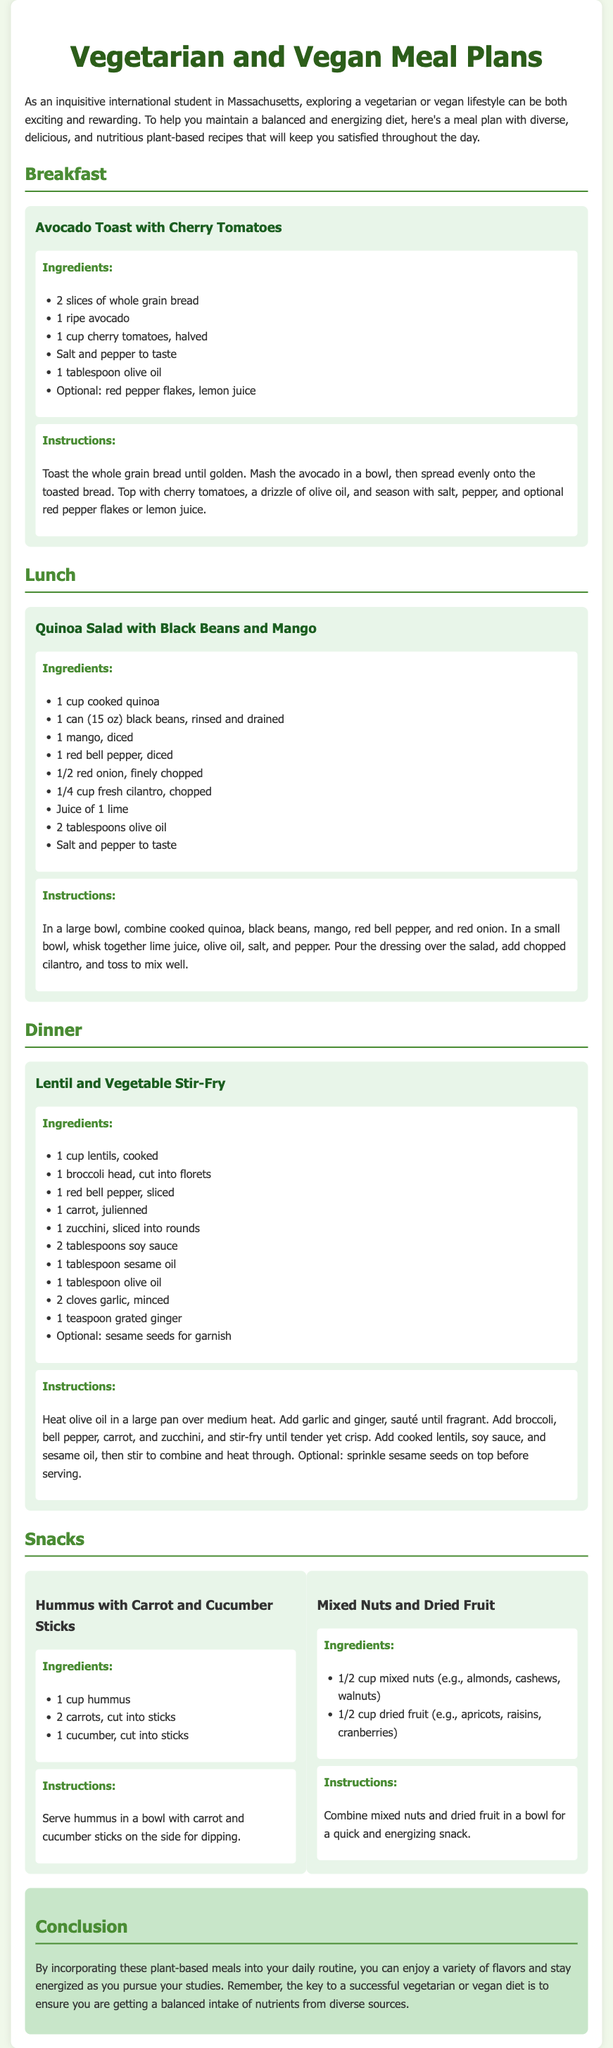What is the title of the document? The title of the document is found in the header section at the top of the page.
Answer: Vegetarian and Vegan Meal Plans How many snacks are listed in the meal plan? The number of snacks can be counted under the Snacks section of the document.
Answer: 2 What is one of the ingredients in the Avocado Toast? The ingredients can be found listed under the meal sections for each recipe.
Answer: Ripe avocado What provides the main protein source in the Quinoa Salad? Identifying the main protein source requires looking at the ingredients in the salad section.
Answer: Black beans What type of oil is used in the Lentil and Vegetable Stir-Fry? The type of oil can be found in the ingredients section related to that meal.
Answer: Sesame oil Which meal includes mango as an ingredient? The meal containing mango can be found by reviewing the ingredients listed in the meals section.
Answer: Quinoa Salad with Black Beans and Mango What are the chopping styles used for the carrot in the Lentil and Vegetable Stir-Fry? The chopping style is specified in the instructions under the ingredients for that meal.
Answer: Julienned How is the Hummus served according to the instructions? The serving method is described in the instructions that follow the ingredient list for the snack.
Answer: In a bowl with sticks on the side for dipping 